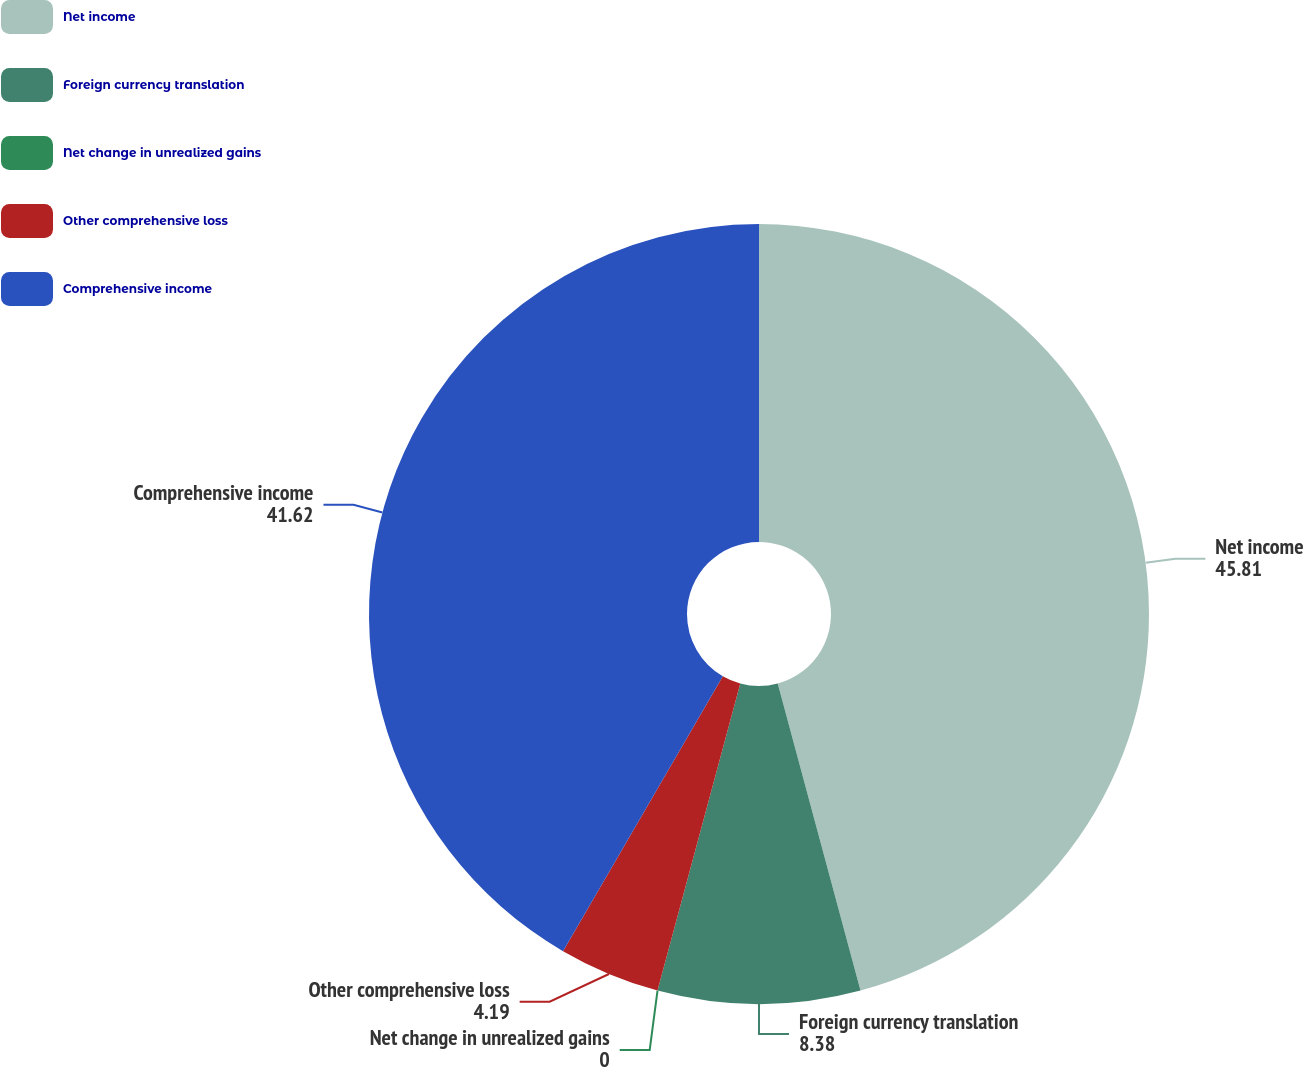<chart> <loc_0><loc_0><loc_500><loc_500><pie_chart><fcel>Net income<fcel>Foreign currency translation<fcel>Net change in unrealized gains<fcel>Other comprehensive loss<fcel>Comprehensive income<nl><fcel>45.81%<fcel>8.38%<fcel>0.0%<fcel>4.19%<fcel>41.62%<nl></chart> 